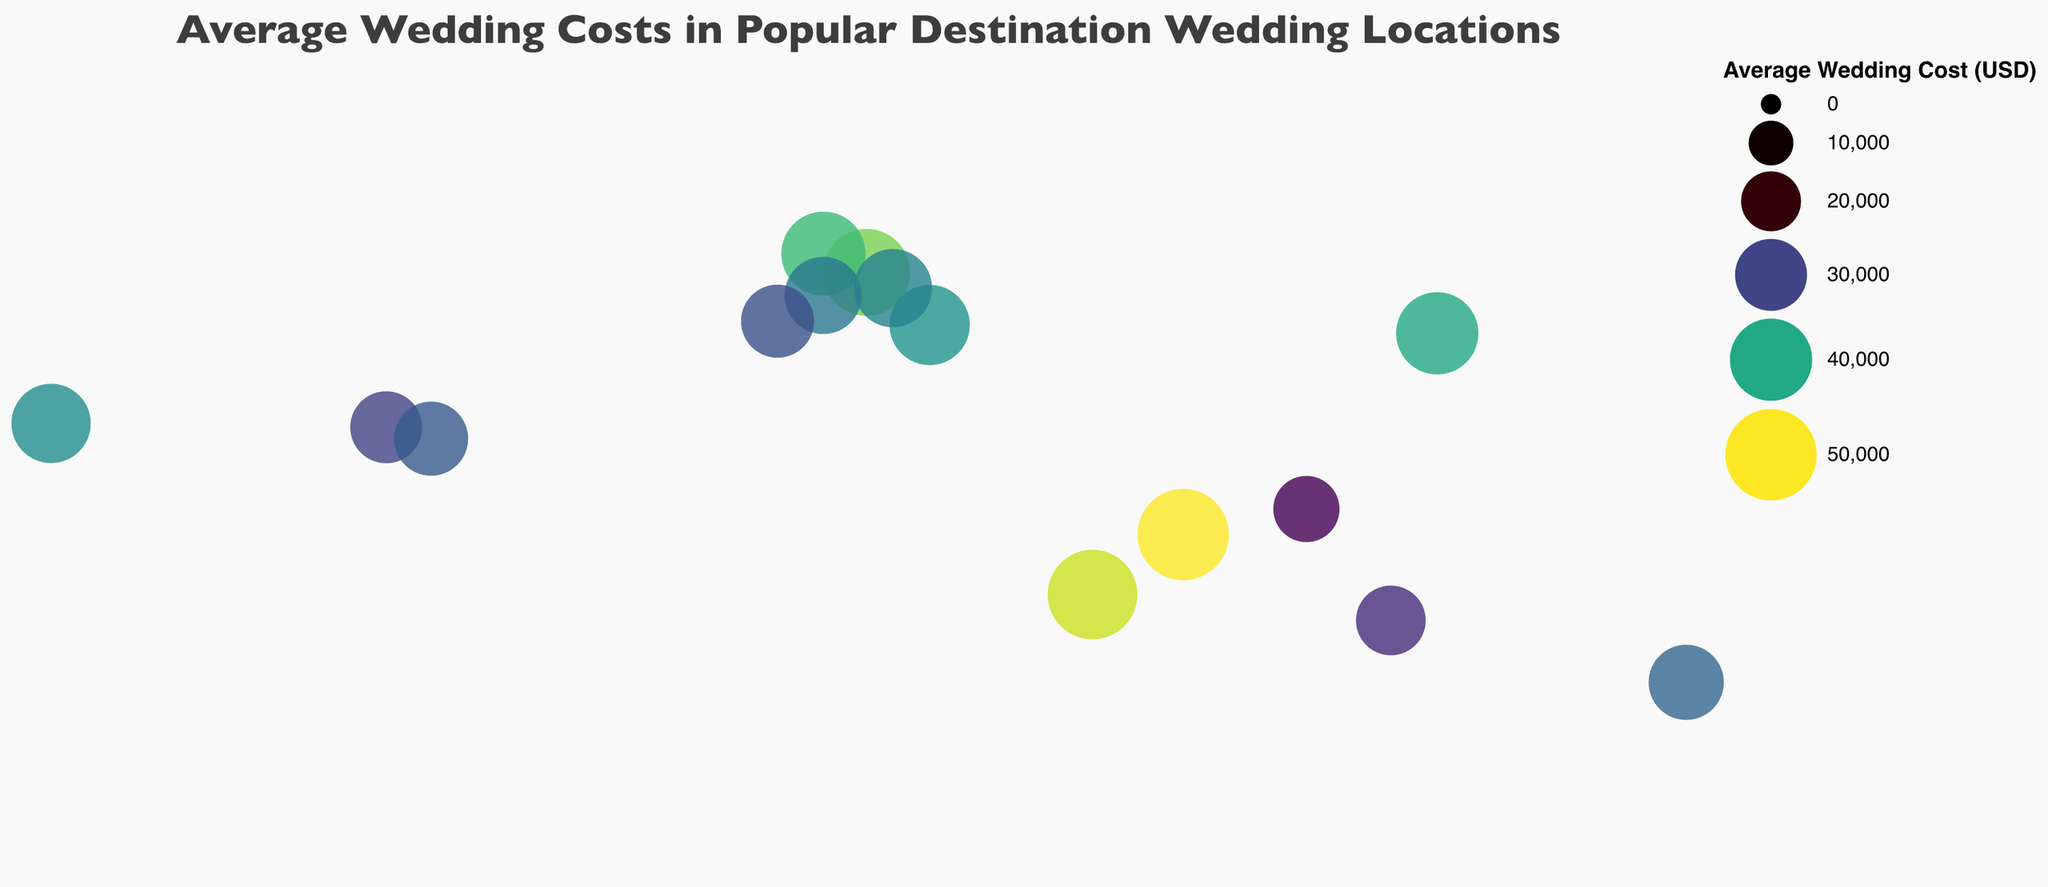Which city has the highest average wedding cost? The highest circle on the map, in terms of color intensity and size, indicates the city with the highest average wedding cost. According to the data, this is Male, Maldives.
Answer: Male, Maldives Which city in Europe has the lowest average wedding cost? From the map, identify the European cities and then compare their average wedding costs by looking at the circle sizes and colors. The European cities are Venice, Santorini, Paris, Barcelona, Algarve, and Dubrovnik, with the lowest average cost being in Algarve, Portugal.
Answer: Algarve, Portugal How does the average wedding cost in Paris compare to that in Montego Bay? Locate Paris and Montego Bay on the map. Compare their circle sizes and colors. Paris has an average wedding cost of $42,000, while Montego Bay has $32,000, making Paris more expensive.
Answer: Paris is more expensive What is the average wedding cost in the city that has the smallest circle on the map? The smallest circle represents the least expensive wedding cost on the map. By identifying it, we find it corresponds to Phuket, Thailand, with an average wedding cost of $25,000.
Answer: $25,000 Are there any cities where the average wedding cost is equal to or more than $48,000? Look for the darkest-colored and largest circles on the map, which indicate the highest costs. According to the data, Male, Maldives, and Mahé, Seychelles, both fit this criterion with costs of $50,000 and $48,000 respectively.
Answer: Male, Maldives, and Mahé, Seychelles Which city has a higher average wedding cost: Barcelona or Kyoto? Compare the circles for Barcelona and Kyoto. The circle size and color for Kyoto indicate an average cost of $40,000, whereas Barcelona is $35,000.
Answer: Kyoto What is the total average wedding cost for the cities in the United States? Find the city in the United States on the map, which is Maui, then note its wedding cost which is $37,000. Since it's the only US city listed, the total is $37,000.
Answer: $37,000 How much more expensive is a wedding in Venice compared to Phuket? Find the circles for Venice and Phuket, note their wedding costs ($45,000 and $25,000 respectively), and calculate the difference: $45,000 - $25,000 = $20,000.
Answer: $20,000 Which cities have a wedding cost within the range of $30,000 to $40,000? Identify the cities on the map with circle sizes and colors corresponding to this cost range. The cities are Santorini ($38,000), Maui ($37,000), Dubrovnik ($36,000), and Montego Bay ($32,000).
Answer: Santorini, Maui, Dubrovnik, Montego Bay 